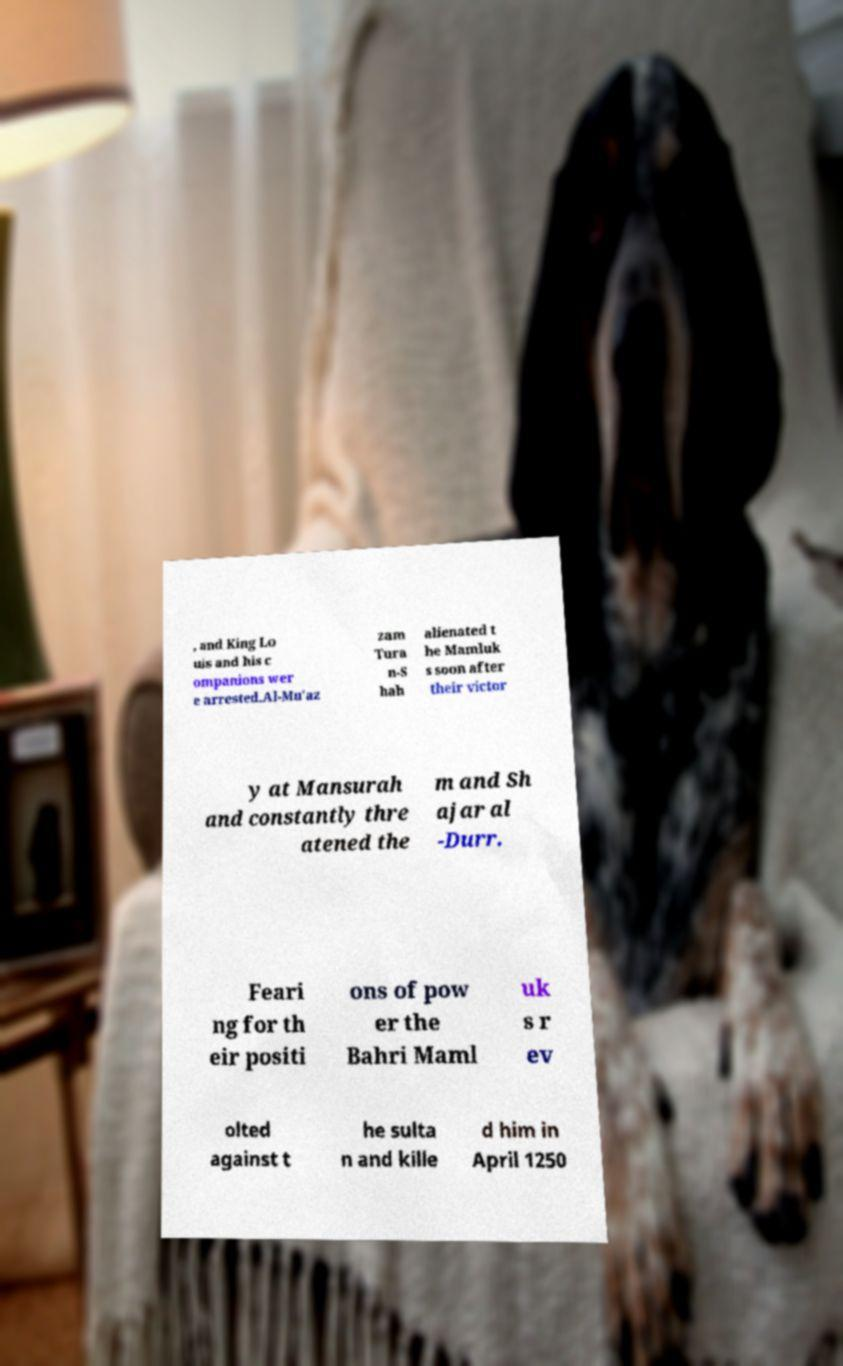Can you accurately transcribe the text from the provided image for me? , and King Lo uis and his c ompanions wer e arrested.Al-Mu'az zam Tura n-S hah alienated t he Mamluk s soon after their victor y at Mansurah and constantly thre atened the m and Sh ajar al -Durr. Feari ng for th eir positi ons of pow er the Bahri Maml uk s r ev olted against t he sulta n and kille d him in April 1250 